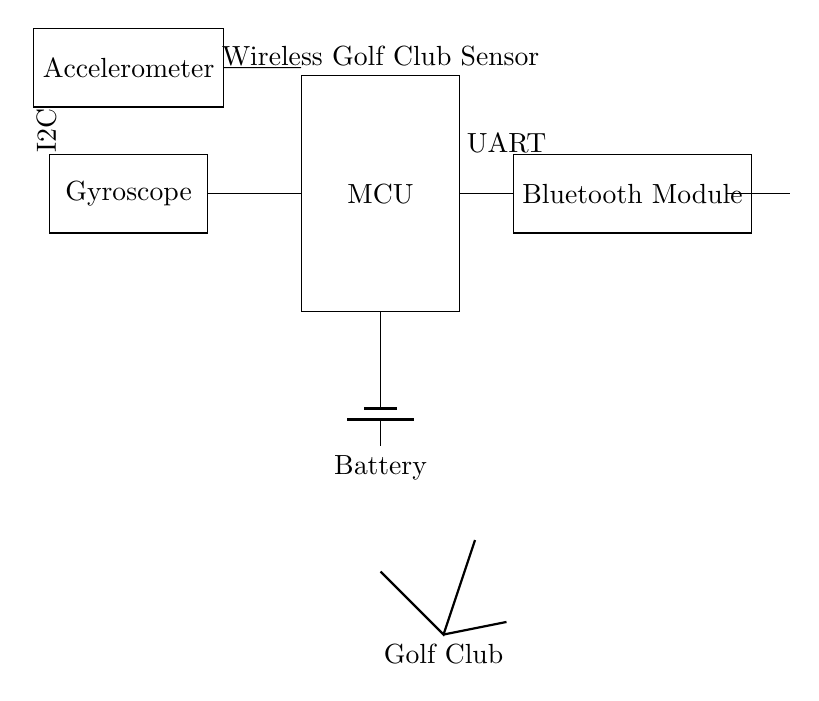What primary components are present in this circuit? The primary components consist of a microcontroller, an accelerometer, a gyroscope, a Bluetooth module, and a battery. These components are depicted in rectangles connected appropriately in the diagram.
Answer: Microcontroller, Accelerometer, Gyroscope, Bluetooth Module, Battery What type of communication is used between the accelerometer and the microcontroller? The accelerometer communicates with the microcontroller via I2C, as indicated by the labeling in the diagram. I2C is typically used for connecting sensors to microcontrollers due to its capability for multiple devices.
Answer: I2C What function does the Bluetooth module serve in this circuit? The Bluetooth module enables wireless communication, allowing the data obtained from the sensors (accelerometer and gyroscope) to be transmitted to a smartphone or other devices. This function is crucial for analysis in swing analysis applications.
Answer: Wireless communication How is power supplied to the microcontroller? The microcontroller receives power from a battery, which is clearly marked in the circuit diagram. The connection from the battery indicates that the microcontroller operates on the battery's voltage.
Answer: Battery What does the antenna represent in this circuit? The antenna in the circuit signifies the wireless transmission capabilities of the Bluetooth module. It serves as the means to send data collected by the sensors away from the golf club to receiving devices.
Answer: Data transmission Which component connects directly to both the accelerometer and gyroscope? The component that connects directly to both the accelerometer and gyroscope is the microcontroller. This connection is essential for processing the sensor data gathered during the golf swing analysis.
Answer: Microcontroller What sensor type is included alongside the accelerometer for swing analysis? The sensor included alongside the accelerometer is a gyroscope. This sensor complements the accelerometer by providing additional data about the rotational motion of the swing, enhancing the analysis of the golfer's swing dynamics.
Answer: Gyroscope 